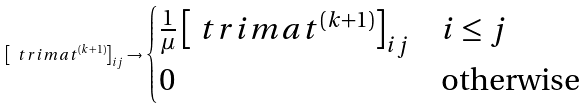<formula> <loc_0><loc_0><loc_500><loc_500>\left [ \ t r i m a t ^ { ( k + 1 ) } \right ] _ { i j } \rightarrow \begin{cases} \frac { 1 } { \mu } \left [ \ t r i m a t ^ { ( k + 1 ) } \right ] _ { i j } & i \leq j \\ 0 & \text {otherwise} \end{cases}</formula> 